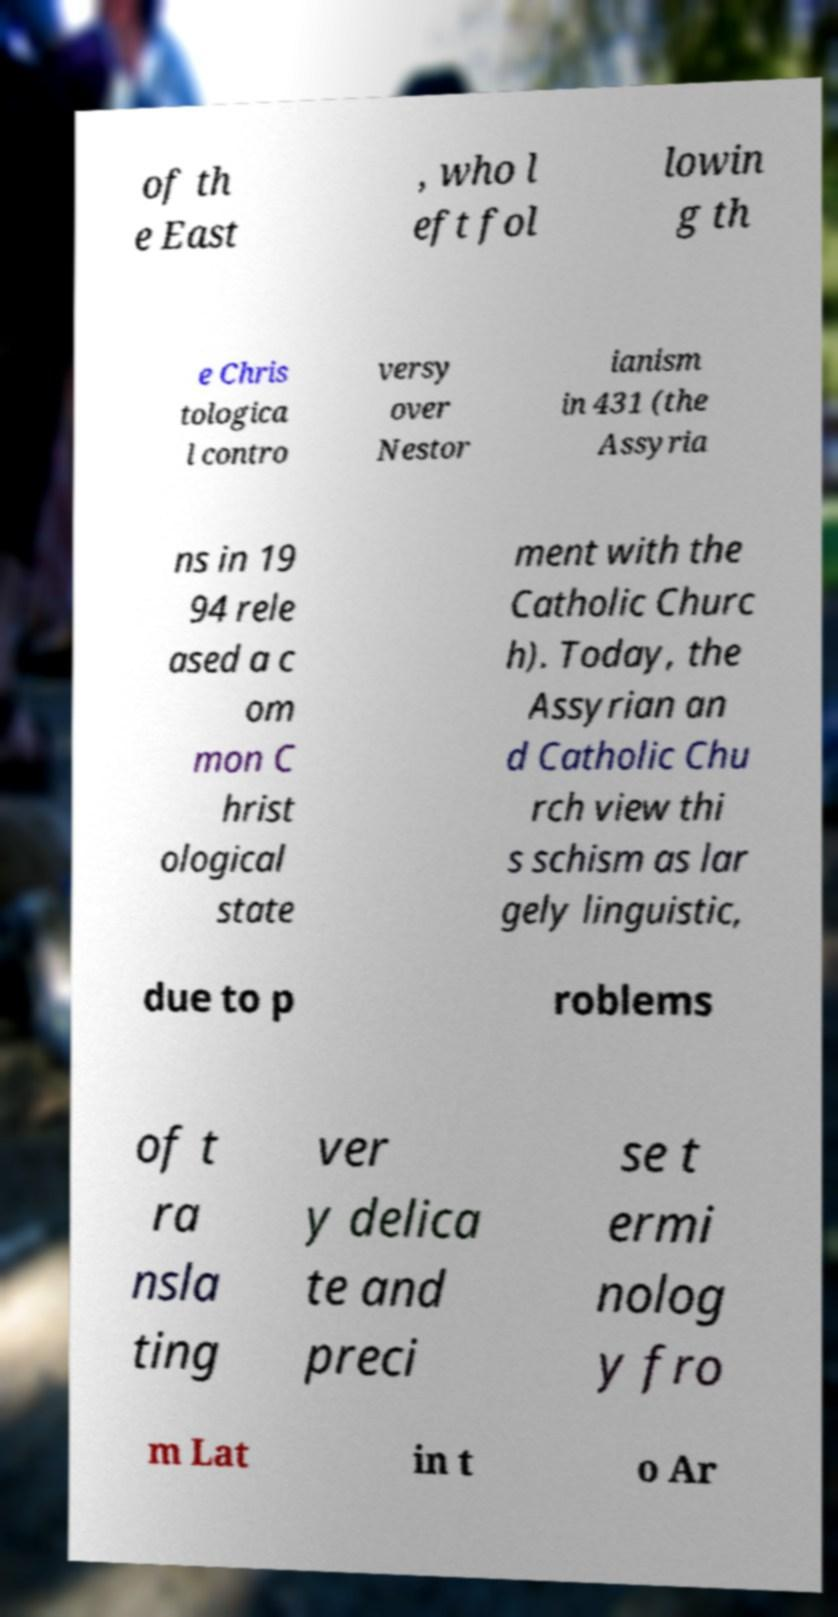Please identify and transcribe the text found in this image. of th e East , who l eft fol lowin g th e Chris tologica l contro versy over Nestor ianism in 431 (the Assyria ns in 19 94 rele ased a c om mon C hrist ological state ment with the Catholic Churc h). Today, the Assyrian an d Catholic Chu rch view thi s schism as lar gely linguistic, due to p roblems of t ra nsla ting ver y delica te and preci se t ermi nolog y fro m Lat in t o Ar 